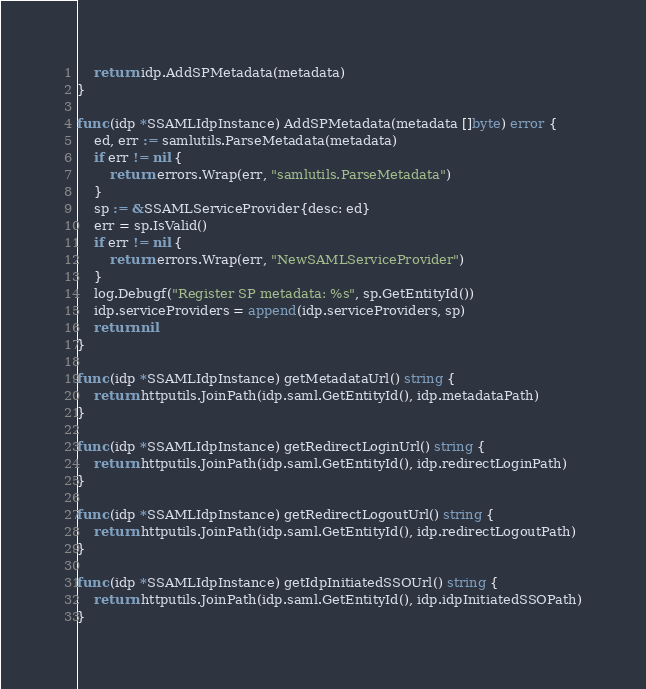<code> <loc_0><loc_0><loc_500><loc_500><_Go_>	return idp.AddSPMetadata(metadata)
}

func (idp *SSAMLIdpInstance) AddSPMetadata(metadata []byte) error {
	ed, err := samlutils.ParseMetadata(metadata)
	if err != nil {
		return errors.Wrap(err, "samlutils.ParseMetadata")
	}
	sp := &SSAMLServiceProvider{desc: ed}
	err = sp.IsValid()
	if err != nil {
		return errors.Wrap(err, "NewSAMLServiceProvider")
	}
	log.Debugf("Register SP metadata: %s", sp.GetEntityId())
	idp.serviceProviders = append(idp.serviceProviders, sp)
	return nil
}

func (idp *SSAMLIdpInstance) getMetadataUrl() string {
	return httputils.JoinPath(idp.saml.GetEntityId(), idp.metadataPath)
}

func (idp *SSAMLIdpInstance) getRedirectLoginUrl() string {
	return httputils.JoinPath(idp.saml.GetEntityId(), idp.redirectLoginPath)
}

func (idp *SSAMLIdpInstance) getRedirectLogoutUrl() string {
	return httputils.JoinPath(idp.saml.GetEntityId(), idp.redirectLogoutPath)
}

func (idp *SSAMLIdpInstance) getIdpInitiatedSSOUrl() string {
	return httputils.JoinPath(idp.saml.GetEntityId(), idp.idpInitiatedSSOPath)
}
</code> 